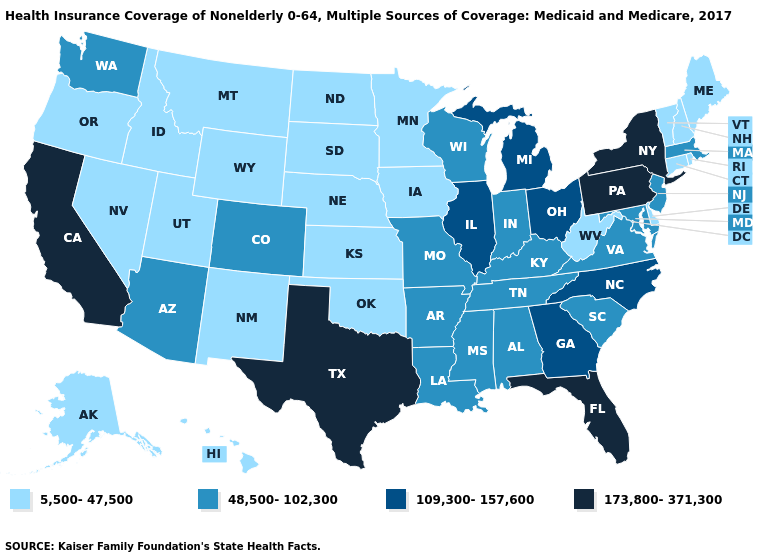Does New Jersey have a higher value than Arkansas?
Write a very short answer. No. Among the states that border Virginia , which have the lowest value?
Short answer required. West Virginia. Which states hav the highest value in the MidWest?
Answer briefly. Illinois, Michigan, Ohio. Which states have the highest value in the USA?
Short answer required. California, Florida, New York, Pennsylvania, Texas. Among the states that border New Jersey , does Delaware have the highest value?
Quick response, please. No. What is the value of Hawaii?
Write a very short answer. 5,500-47,500. What is the value of Montana?
Short answer required. 5,500-47,500. Among the states that border Wyoming , which have the highest value?
Give a very brief answer. Colorado. Name the states that have a value in the range 109,300-157,600?
Write a very short answer. Georgia, Illinois, Michigan, North Carolina, Ohio. Name the states that have a value in the range 5,500-47,500?
Be succinct. Alaska, Connecticut, Delaware, Hawaii, Idaho, Iowa, Kansas, Maine, Minnesota, Montana, Nebraska, Nevada, New Hampshire, New Mexico, North Dakota, Oklahoma, Oregon, Rhode Island, South Dakota, Utah, Vermont, West Virginia, Wyoming. What is the value of Pennsylvania?
Quick response, please. 173,800-371,300. Which states hav the highest value in the West?
Give a very brief answer. California. Name the states that have a value in the range 5,500-47,500?
Give a very brief answer. Alaska, Connecticut, Delaware, Hawaii, Idaho, Iowa, Kansas, Maine, Minnesota, Montana, Nebraska, Nevada, New Hampshire, New Mexico, North Dakota, Oklahoma, Oregon, Rhode Island, South Dakota, Utah, Vermont, West Virginia, Wyoming. What is the value of North Dakota?
Short answer required. 5,500-47,500. Among the states that border Indiana , which have the lowest value?
Write a very short answer. Kentucky. 